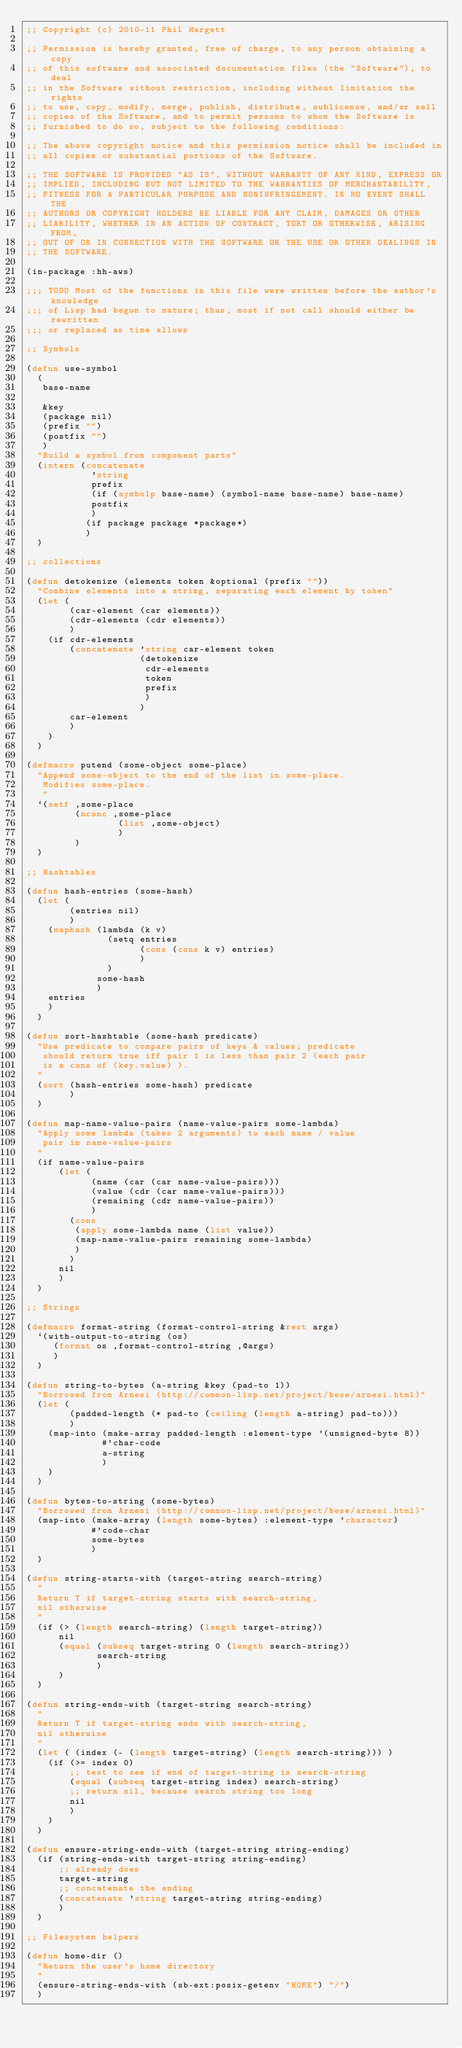<code> <loc_0><loc_0><loc_500><loc_500><_Lisp_>;; Copyright (c) 2010-11 Phil Hargett

;; Permission is hereby granted, free of charge, to any person obtaining a copy
;; of this software and associated documentation files (the "Software"), to deal
;; in the Software without restriction, including without limitation the rights
;; to use, copy, modify, merge, publish, distribute, sublicense, and/or sell
;; copies of the Software, and to permit persons to whom the Software is
;; furnished to do so, subject to the following conditions:

;; The above copyright notice and this permission notice shall be included in
;; all copies or substantial portions of the Software.

;; THE SOFTWARE IS PROVIDED "AS IS", WITHOUT WARRANTY OF ANY KIND, EXPRESS OR
;; IMPLIED, INCLUDING BUT NOT LIMITED TO THE WARRANTIES OF MERCHANTABILITY,
;; FITNESS FOR A PARTICULAR PURPOSE AND NONINFRINGEMENT. IN NO EVENT SHALL THE
;; AUTHORS OR COPYRIGHT HOLDERS BE LIABLE FOR ANY CLAIM, DAMAGES OR OTHER
;; LIABILITY, WHETHER IN AN ACTION OF CONTRACT, TORT OR OTHERWISE, ARISING FROM,
;; OUT OF OR IN CONNECTION WITH THE SOFTWARE OR THE USE OR OTHER DEALINGS IN
;; THE SOFTWARE.

(in-package :hh-aws)

;;; TODO Most of the functions in this file were written before the author's knowledge
;;; of Lisp had begun to mature; thus, most if not call should either be rewritten
;;; or replaced as time allows

;; Symbols

(defun use-symbol 
  (
   base-name
   
   &key 
   (package nil)
   (prefix "")
   (postfix "")                    
   )
  "Build a symbol from component parts"
  (intern (concatenate 
            'string
            prefix
            (if (symbolp base-name) (symbol-name base-name) base-name)
            postfix
            ) 
           (if package package *package*)
           )
  )

;; collections

(defun detokenize (elements token &optional (prefix ""))
  "Combine elements into a string, separating each element by token"
  (let ( 
        (car-element (car elements))
        (cdr-elements (cdr elements))
        )
    (if cdr-elements
        (concatenate 'string car-element token
                     (detokenize 
                      cdr-elements 
                      token
                      prefix 
                      )
                     )
        car-element
        )
    )
  )

(defmacro putend (some-object some-place)
  "Append some-object to the end of the list in some-place.
   Modifies some-place.
   "
  `(setf ,some-place
         (nconc ,some-place
                 (list ,some-object)
                 )
         )
  )

;; Hashtables

(defun hash-entries (some-hash)
  (let ( 
        (entries nil) 
        )
    (maphash (lambda (k v)
               (setq entries
                     (cons (cons k v) entries)
                     )
               )
             some-hash
             )
    entries
    )
  )

(defun sort-hashtable (some-hash predicate)
  "Use predicate to compare pairs of keys & values; predicate
   should return true iff pair 1 is less than pair 2 (each pair
   is a cons of (key.value) ). 
  "
  (sort (hash-entries some-hash) predicate
        )
  )

(defun map-name-value-pairs (name-value-pairs some-lambda)
  "Apply some lambda (takes 2 arguments) to each name / value
   pair in name-value-pairs
  "
  (if name-value-pairs
      (let (
            (name (car (car name-value-pairs)))
            (value (cdr (car name-value-pairs)))
            (remaining (cdr name-value-pairs))
            )
        (cons
         (apply some-lambda name (list value))
         (map-name-value-pairs remaining some-lambda)
         )
        )
      nil
      )
  )

;; Strings

(defmacro format-string (format-control-string &rest args)
  `(with-output-to-string (os)
     (format os ,format-control-string ,@args)
     )
  )

(defun string-to-bytes (a-string &key (pad-to 1))
  "Borrowed from Arnesi (http://common-lisp.net/project/bese/arnesi.html)"
  (let ( 
        (padded-length (* pad-to (ceiling (length a-string) pad-to)))
        )
    (map-into (make-array padded-length :element-type '(unsigned-byte 8))
              #'char-code 
              a-string
              )
    )
  )
  
(defun bytes-to-string (some-bytes)
  "Borrowed from Arnesi (http://common-lisp.net/project/bese/arnesi.html)"
  (map-into (make-array (length some-bytes) :element-type 'character)
            #'code-char 
            some-bytes
            )
  )

(defun string-starts-with (target-string search-string)
  "
  Return T if target-string starts with search-string, 
  nil otherwise 
  "
  (if (> (length search-string) (length target-string))
      nil
      (equal (subseq target-string 0 (length search-string)) 
             search-string
             )    
      )
  )

(defun string-ends-with (target-string search-string)
  "
  Return T if target-string ends with search-string, 
  nil otherwise 
  "
  (let ( (index (- (length target-string) (length search-string))) )
    (if (>= index 0)
        ;; test to see if end of target-string is search-string 
        (equal (subseq target-string index) search-string)
        ;; return nil, because search string too long
        nil
        ) 
    )
  )

(defun ensure-string-ends-with (target-string string-ending)
  (if (string-ends-with target-string string-ending)
      ;; already does
      target-string
      ;; concatenate the ending
      (concatenate 'string target-string string-ending)
      )
  )

;; Filesystem helpers

(defun home-dir ()
  "Return the user's home directory
  "
  (ensure-string-ends-with (sb-ext:posix-getenv "HOME") "/")
  )
</code> 